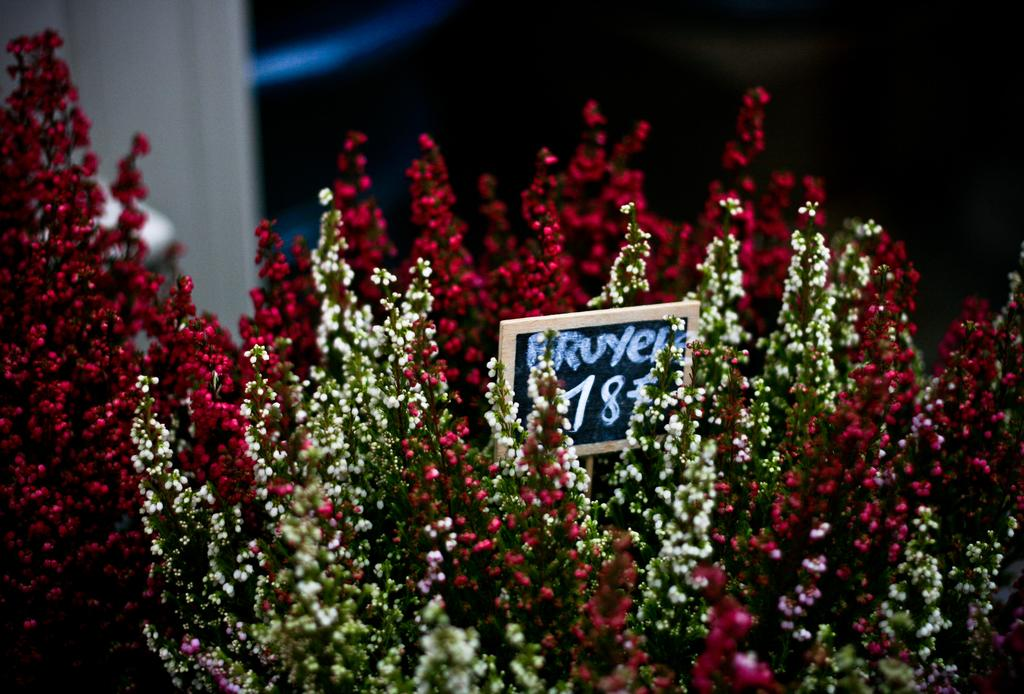What is the main subject of the image? The main subject of the image is a bouquet. What can be found on the price board in the bouquet? The price board in the bouquet contains prices. What type of items are included in the bouquet? The bouquet contains flowers. Can you describe the background of the image? The background of the image is blurry. What type of leather is visible in the image? There is no leather present in the image. What authority figure can be seen in the image? There is no authority figure present in the image. 